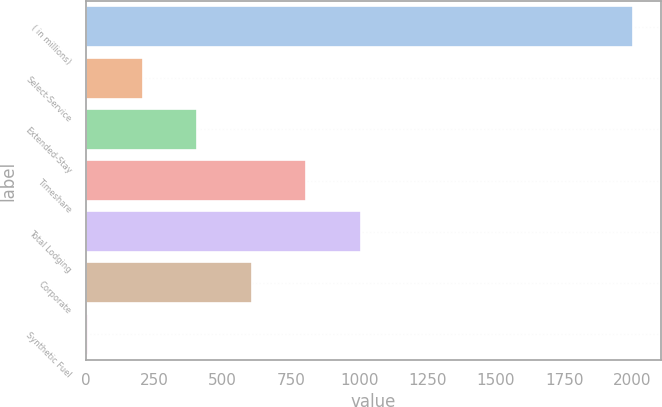Convert chart. <chart><loc_0><loc_0><loc_500><loc_500><bar_chart><fcel>( in millions)<fcel>Select-Service<fcel>Extended-Stay<fcel>Timeshare<fcel>Total Lodging<fcel>Corporate<fcel>Synthetic Fuel<nl><fcel>2003<fcel>207.5<fcel>407<fcel>806<fcel>1005.5<fcel>606.5<fcel>8<nl></chart> 